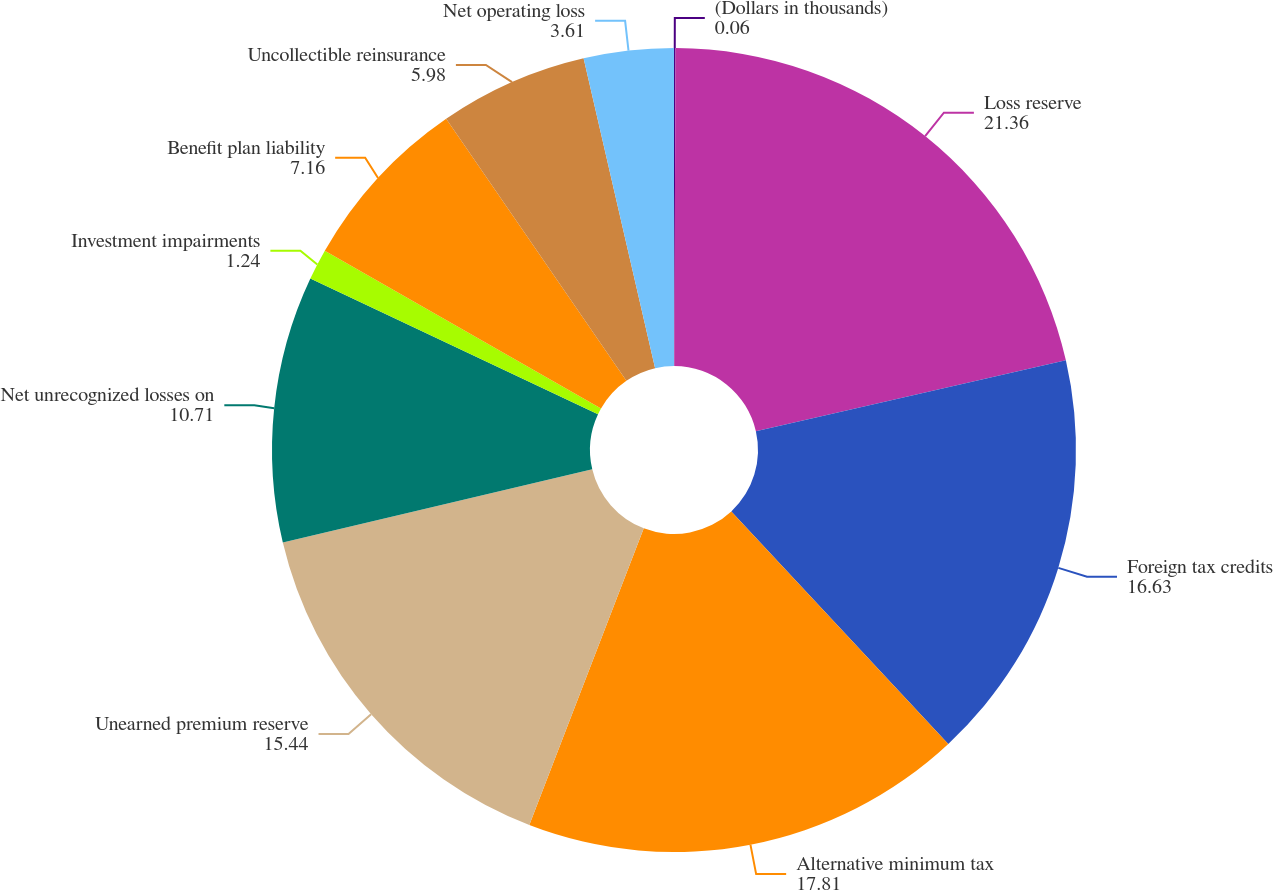<chart> <loc_0><loc_0><loc_500><loc_500><pie_chart><fcel>(Dollars in thousands)<fcel>Loss reserve<fcel>Foreign tax credits<fcel>Alternative minimum tax<fcel>Unearned premium reserve<fcel>Net unrecognized losses on<fcel>Investment impairments<fcel>Benefit plan liability<fcel>Uncollectible reinsurance<fcel>Net operating loss<nl><fcel>0.06%<fcel>21.36%<fcel>16.63%<fcel>17.81%<fcel>15.44%<fcel>10.71%<fcel>1.24%<fcel>7.16%<fcel>5.98%<fcel>3.61%<nl></chart> 